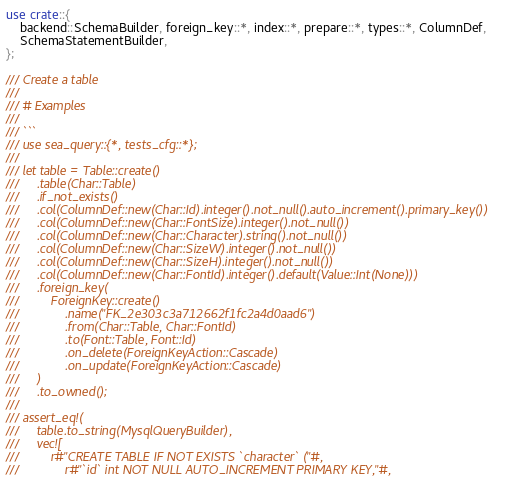Convert code to text. <code><loc_0><loc_0><loc_500><loc_500><_Rust_>use crate::{
    backend::SchemaBuilder, foreign_key::*, index::*, prepare::*, types::*, ColumnDef,
    SchemaStatementBuilder,
};

/// Create a table
///
/// # Examples
///
/// ```
/// use sea_query::{*, tests_cfg::*};
///
/// let table = Table::create()
///     .table(Char::Table)
///     .if_not_exists()
///     .col(ColumnDef::new(Char::Id).integer().not_null().auto_increment().primary_key())
///     .col(ColumnDef::new(Char::FontSize).integer().not_null())
///     .col(ColumnDef::new(Char::Character).string().not_null())
///     .col(ColumnDef::new(Char::SizeW).integer().not_null())
///     .col(ColumnDef::new(Char::SizeH).integer().not_null())
///     .col(ColumnDef::new(Char::FontId).integer().default(Value::Int(None)))
///     .foreign_key(
///         ForeignKey::create()
///             .name("FK_2e303c3a712662f1fc2a4d0aad6")
///             .from(Char::Table, Char::FontId)
///             .to(Font::Table, Font::Id)
///             .on_delete(ForeignKeyAction::Cascade)
///             .on_update(ForeignKeyAction::Cascade)
///     )
///     .to_owned();
///
/// assert_eq!(
///     table.to_string(MysqlQueryBuilder),
///     vec![
///         r#"CREATE TABLE IF NOT EXISTS `character` ("#,
///             r#"`id` int NOT NULL AUTO_INCREMENT PRIMARY KEY,"#,</code> 